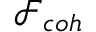<formula> <loc_0><loc_0><loc_500><loc_500>\mathcal { F } _ { c o h }</formula> 